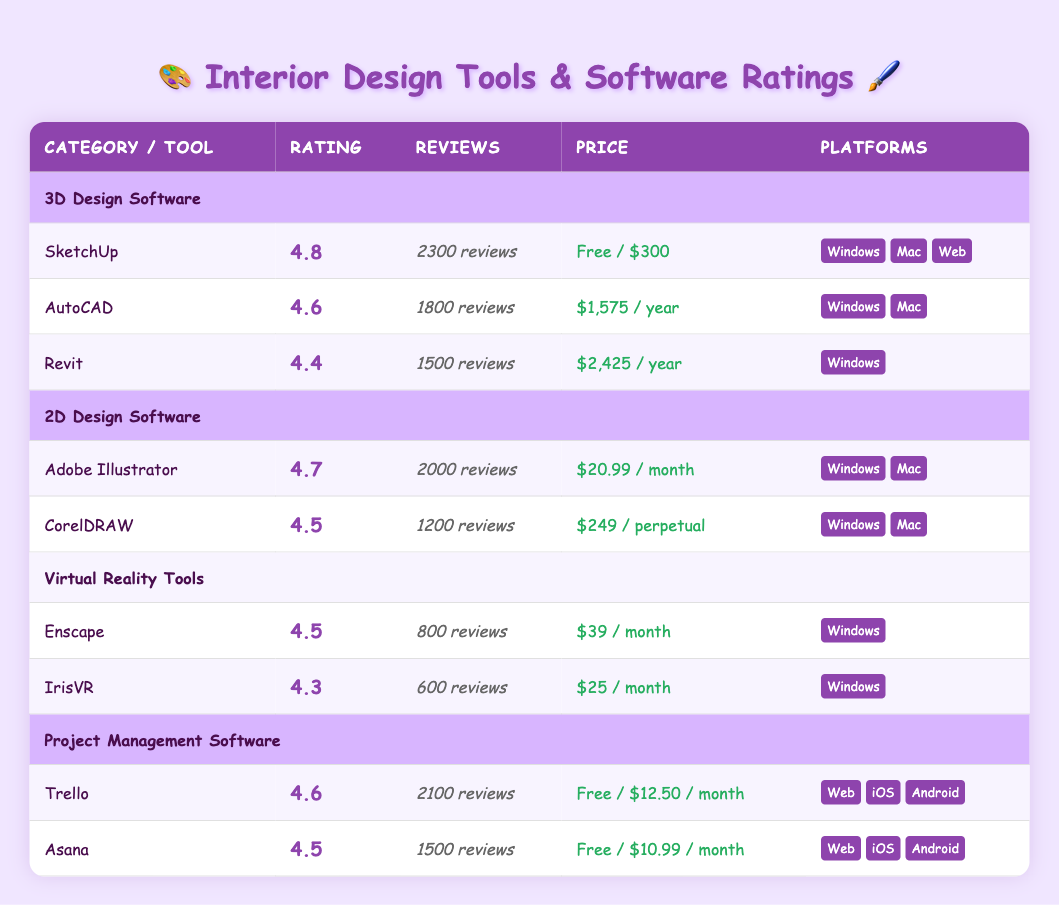What is the highest rated 3D design software? The table shows that SketchUp has the highest rating among 3D design software with a score of 4.8.
Answer: SketchUp How many reviews does AutoCAD have? According to the table, AutoCAD has 1800 reviews noted next to its rating.
Answer: 1800 reviews Which software in the Virtual Reality Tools category has the lowest rating? In the Virtual Reality Tools category, IrisVR has the lowest rating at 4.3, as seen in the table.
Answer: IrisVR What is the average rating of the Project Management Software? To get the average rating, we sum the ratings of Trello (4.6) and Asana (4.5), which equals 9.1. Dividing by the number of tools (2), the average rating is 9.1 / 2 = 4.55.
Answer: 4.55 Is Revit available on Mac? The table indicates that Revit is only available on Windows and does not mention Mac, so the answer is no.
Answer: No How many total reviews do the 2D Design Software options have combined? The total number of reviews for the 2D Design Software options (Adobe Illustrator having 2000 reviews and CorelDRAW with 1200 reviews) is calculated like this: 2000 + 1200 = 3200.
Answer: 3200 Which tool offers the lowest monthly price? The table shows that IrisVR offers the lowest monthly price at $25/month, among the listed software and tools.
Answer: $25/month How many platforms does Adobe Illustrator support? Adobe Illustrator supports two platforms, as indicated in the table: Windows and Mac.
Answer: 2 platforms What is the price range for Trello? The table states Trello has a price range of Free / $12.50 per month. Thus, the price range includes both options mentioned.
Answer: Free / $12.50 / month 